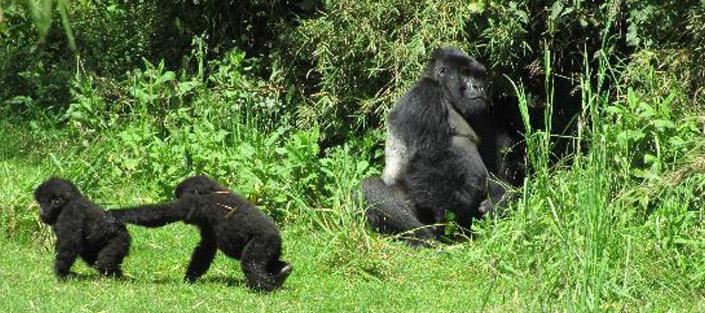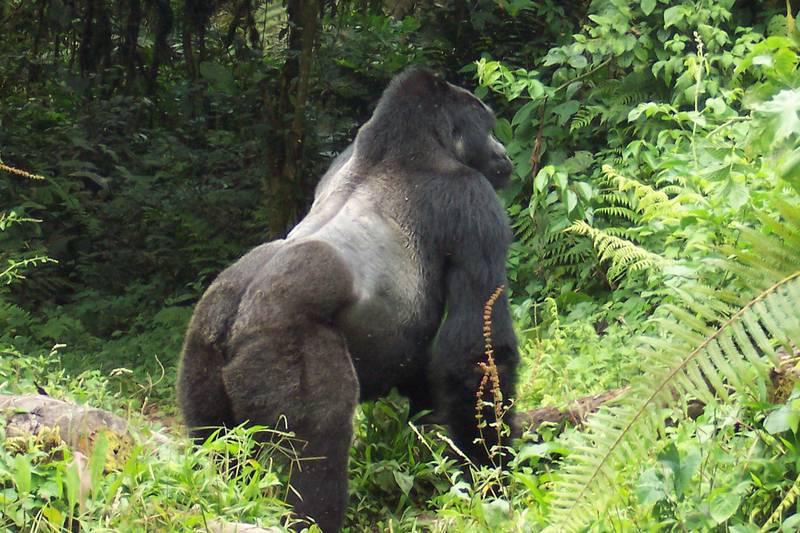The first image is the image on the left, the second image is the image on the right. For the images displayed, is the sentence "There are two adult gurallies and two baby gurilles.  gorialles gore" factually correct? Answer yes or no. Yes. The first image is the image on the left, the second image is the image on the right. Evaluate the accuracy of this statement regarding the images: "In one image, one gorilla is walking leftward behind another and reaching an arm out to touch it.". Is it true? Answer yes or no. Yes. 